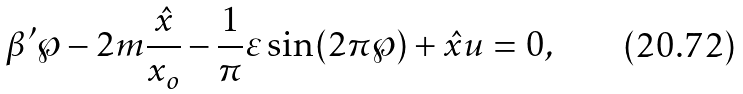Convert formula to latex. <formula><loc_0><loc_0><loc_500><loc_500>\beta ^ { \prime } \wp - 2 m \frac { \hat { x } } { x _ { o } } - \frac { 1 } { \pi } \varepsilon \sin ( 2 \pi \wp ) + \hat { x } u = 0 ,</formula> 